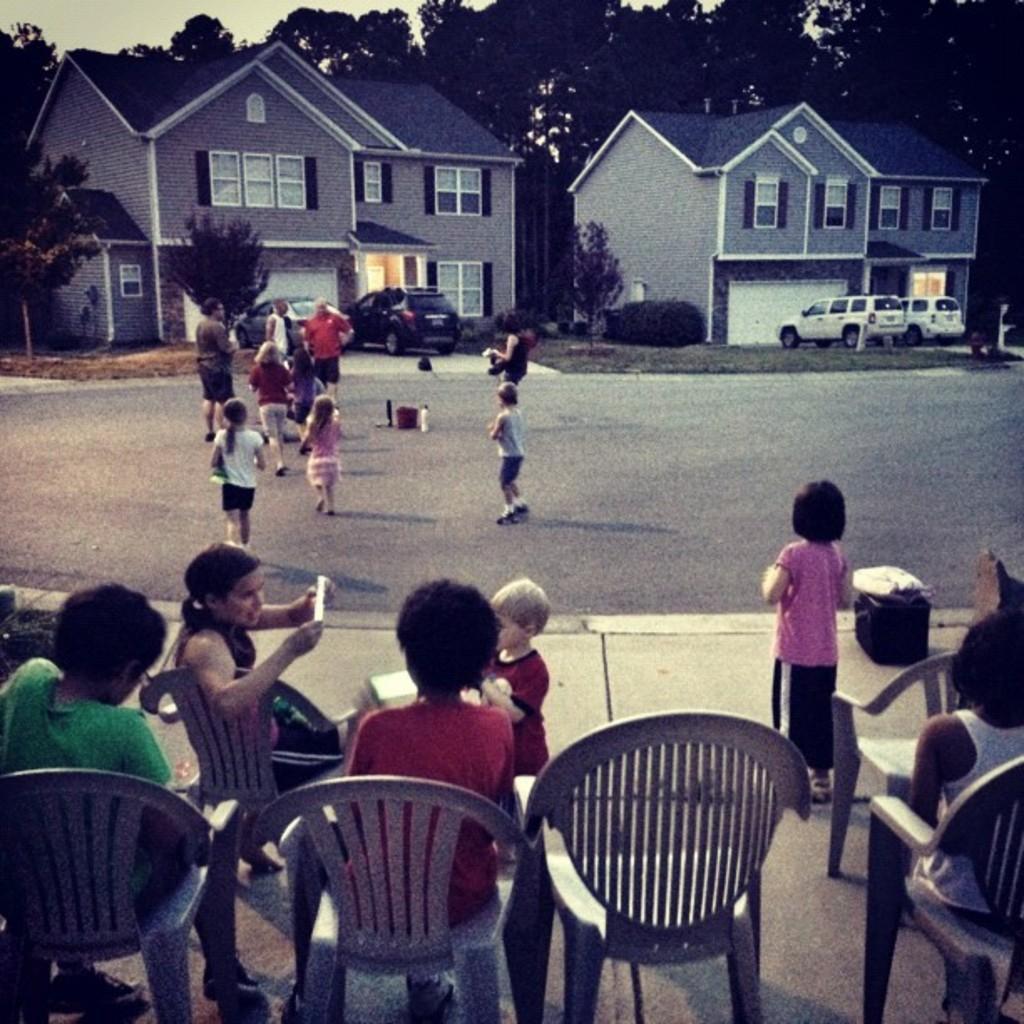How would you summarize this image in a sentence or two? This is a picture taken in the outdoor, there are the kids playing on the road and some kids are sitting on the chair. Background of the persons there are two houses and the cars were parking in front of the houses and there are the trees and background of the house is sky. 